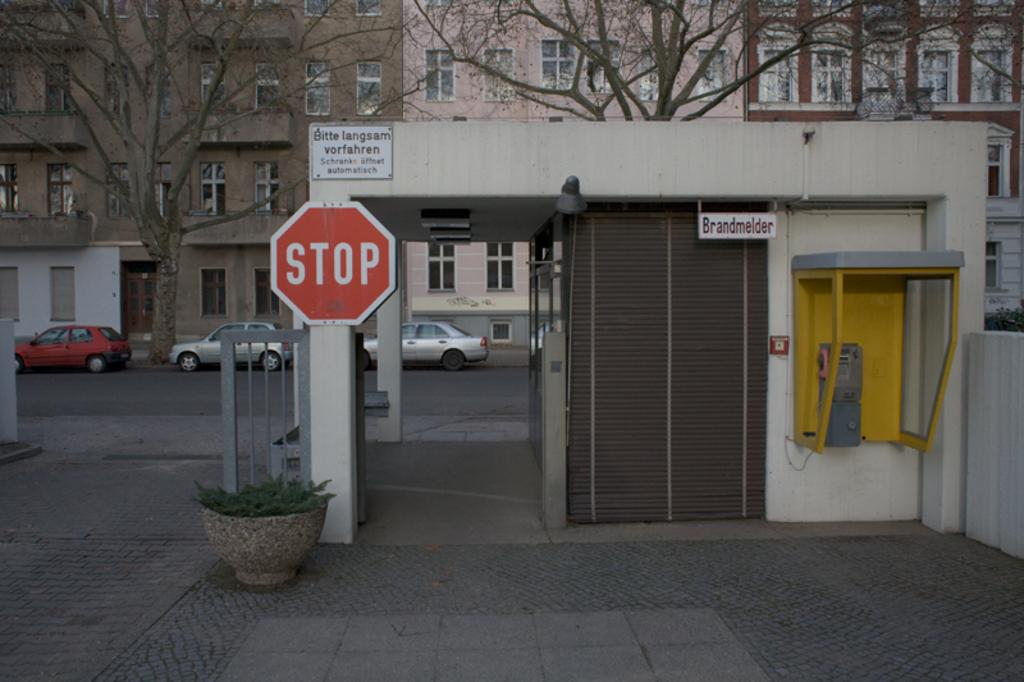What type of plant is visible in the image? There is a plant in the image, but its specific type cannot be determined from the provided facts. What can be seen in the image besides the plant? There are boards, a shutter, pillars, a wall, bare trees, buildings, and vehicles on the road visible in the image. What architectural features are present in the image? The image features pillars and a wall. What is the setting of the image? The image shows a scene with buildings, roads, and trees, suggesting an urban or suburban environment. Can you describe the cast of the movie that is being filmed in the image? There is no indication in the image that a movie is being filmed, nor is there any information about a cast. Is there a squirrel visible in the image? There is no squirrel present in the image. 